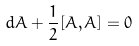Convert formula to latex. <formula><loc_0><loc_0><loc_500><loc_500>d A + \frac { 1 } { 2 } [ A , A ] = 0</formula> 